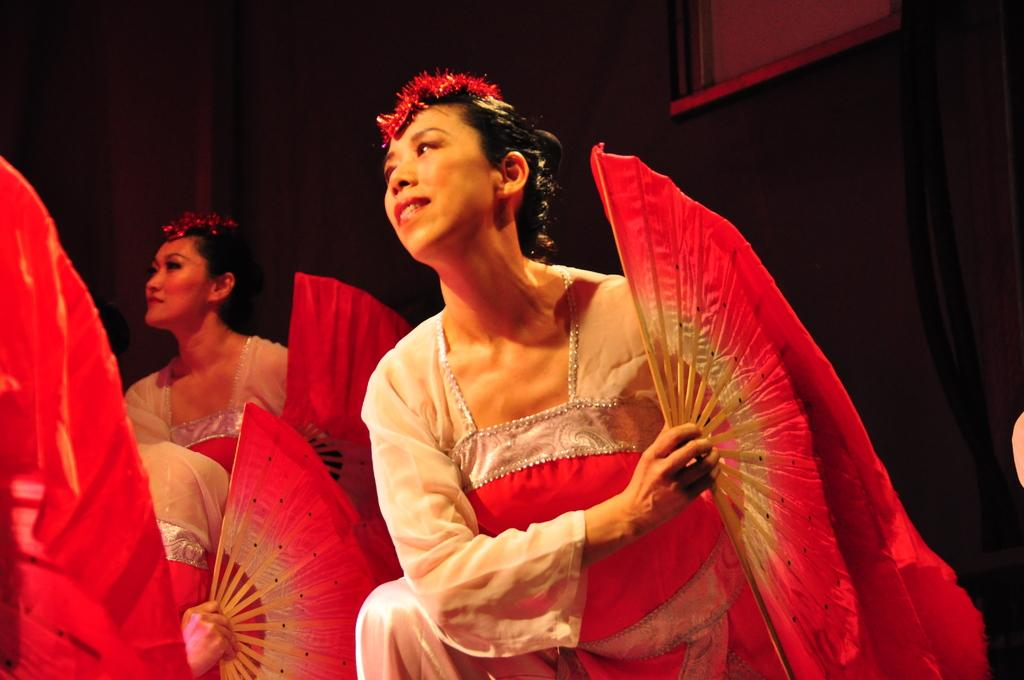What is the main subject of the image? The main subject of the image is a group of people. What are the people holding in their hands? The people are holding hand fans in their hands. Can you describe the background of the image? There is a frame on the wall in the background of the image. How much money is being exchanged between the people in the image? There is no indication of money being exchanged in the image; the people are holding hand fans. What role does the father play in the image? There is no mention of a father or any familial relationships in the image; it simply features a group of people holding hand fans. 